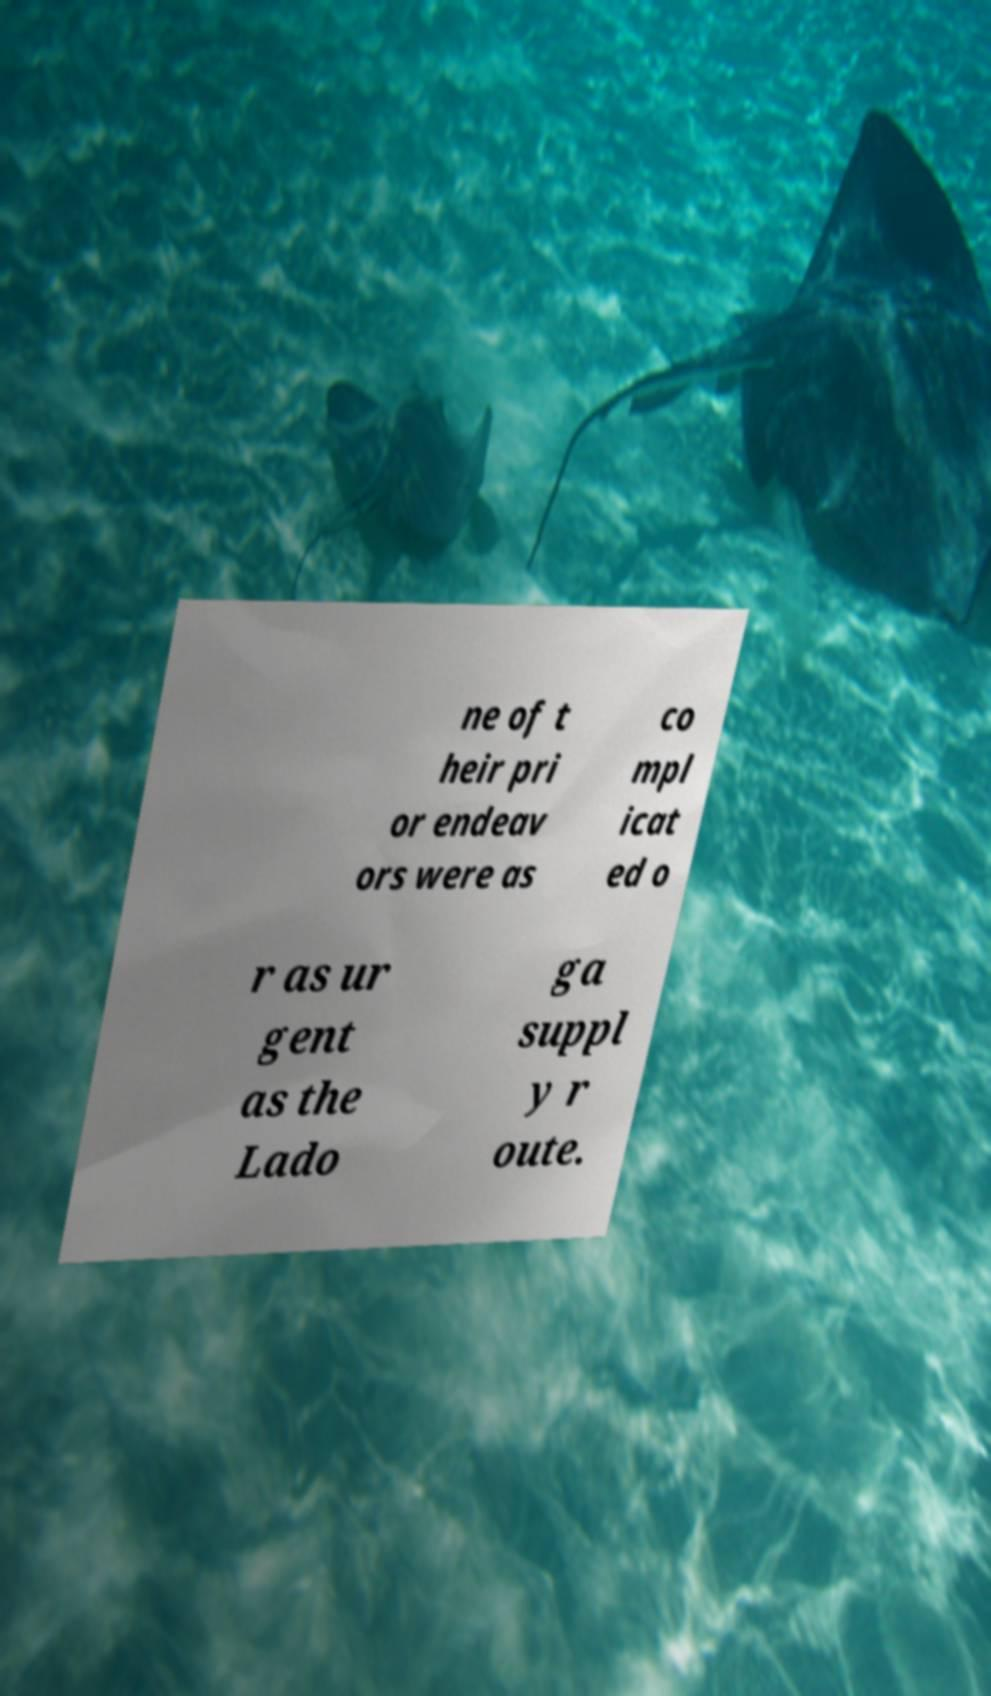Could you assist in decoding the text presented in this image and type it out clearly? ne of t heir pri or endeav ors were as co mpl icat ed o r as ur gent as the Lado ga suppl y r oute. 